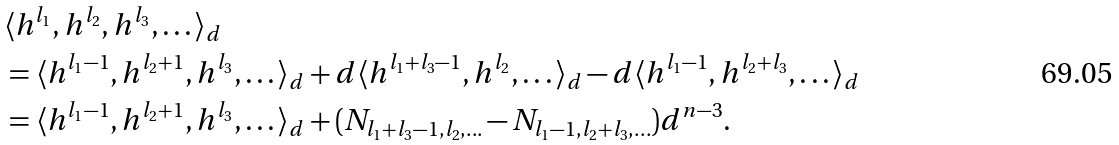Convert formula to latex. <formula><loc_0><loc_0><loc_500><loc_500>& \langle h ^ { l _ { 1 } } , h ^ { l _ { 2 } } , h ^ { l _ { 3 } } , \dots \rangle _ { d } \\ & = \langle h ^ { l _ { 1 } - 1 } , h ^ { l _ { 2 } + 1 } , h ^ { l _ { 3 } } , \dots \rangle _ { d } + d \langle h ^ { l _ { 1 } + l _ { 3 } - 1 } , h ^ { l _ { 2 } } , \dots \rangle _ { d } - d \langle h ^ { l _ { 1 } - 1 } , h ^ { l _ { 2 } + l _ { 3 } } , \dots \rangle _ { d } \\ & = \langle h ^ { l _ { 1 } - 1 } , h ^ { l _ { 2 } + 1 } , h ^ { l _ { 3 } } , \dots \rangle _ { d } + ( N _ { l _ { 1 } + l _ { 3 } - 1 , l _ { 2 } , \dots } - N _ { l _ { 1 } - 1 , l _ { 2 } + l _ { 3 } , \dots } ) d ^ { n - 3 } .</formula> 